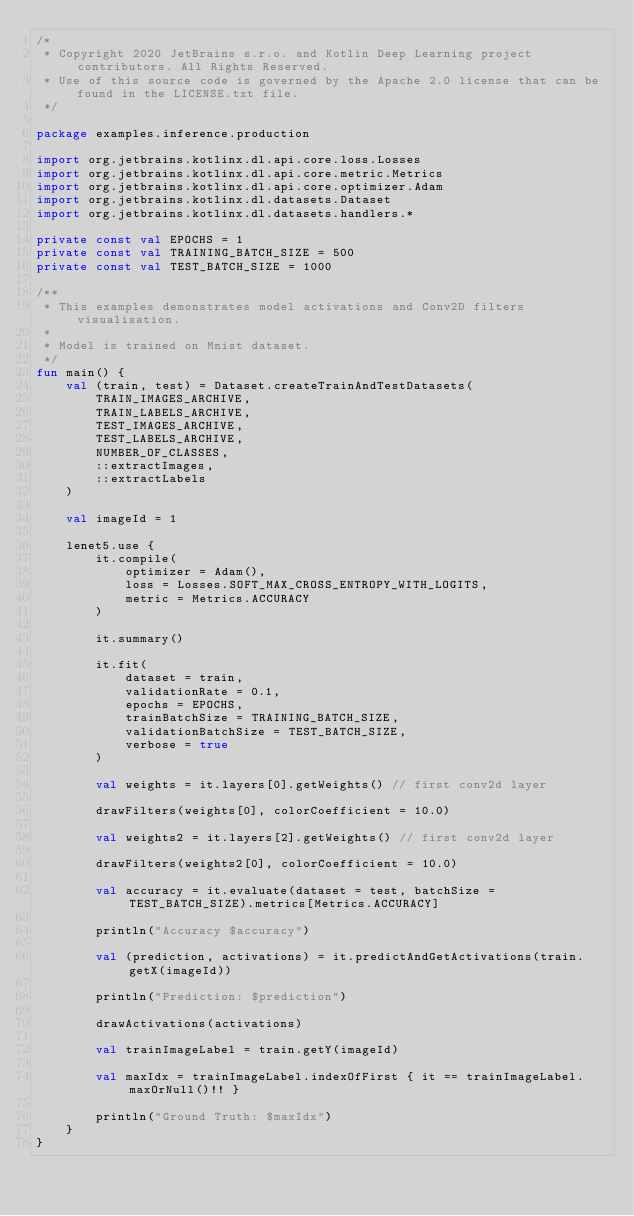Convert code to text. <code><loc_0><loc_0><loc_500><loc_500><_Kotlin_>/*
 * Copyright 2020 JetBrains s.r.o. and Kotlin Deep Learning project contributors. All Rights Reserved.
 * Use of this source code is governed by the Apache 2.0 license that can be found in the LICENSE.txt file.
 */

package examples.inference.production

import org.jetbrains.kotlinx.dl.api.core.loss.Losses
import org.jetbrains.kotlinx.dl.api.core.metric.Metrics
import org.jetbrains.kotlinx.dl.api.core.optimizer.Adam
import org.jetbrains.kotlinx.dl.datasets.Dataset
import org.jetbrains.kotlinx.dl.datasets.handlers.*

private const val EPOCHS = 1
private const val TRAINING_BATCH_SIZE = 500
private const val TEST_BATCH_SIZE = 1000

/**
 * This examples demonstrates model activations and Conv2D filters visualisation.
 *
 * Model is trained on Mnist dataset.
 */
fun main() {
    val (train, test) = Dataset.createTrainAndTestDatasets(
        TRAIN_IMAGES_ARCHIVE,
        TRAIN_LABELS_ARCHIVE,
        TEST_IMAGES_ARCHIVE,
        TEST_LABELS_ARCHIVE,
        NUMBER_OF_CLASSES,
        ::extractImages,
        ::extractLabels
    )

    val imageId = 1

    lenet5.use {
        it.compile(
            optimizer = Adam(),
            loss = Losses.SOFT_MAX_CROSS_ENTROPY_WITH_LOGITS,
            metric = Metrics.ACCURACY
        )

        it.summary()

        it.fit(
            dataset = train,
            validationRate = 0.1,
            epochs = EPOCHS,
            trainBatchSize = TRAINING_BATCH_SIZE,
            validationBatchSize = TEST_BATCH_SIZE,
            verbose = true
        )

        val weights = it.layers[0].getWeights() // first conv2d layer

        drawFilters(weights[0], colorCoefficient = 10.0)

        val weights2 = it.layers[2].getWeights() // first conv2d layer

        drawFilters(weights2[0], colorCoefficient = 10.0)

        val accuracy = it.evaluate(dataset = test, batchSize = TEST_BATCH_SIZE).metrics[Metrics.ACCURACY]

        println("Accuracy $accuracy")

        val (prediction, activations) = it.predictAndGetActivations(train.getX(imageId))

        println("Prediction: $prediction")

        drawActivations(activations)

        val trainImageLabel = train.getY(imageId)

        val maxIdx = trainImageLabel.indexOfFirst { it == trainImageLabel.maxOrNull()!! }

        println("Ground Truth: $maxIdx")
    }
}
</code> 